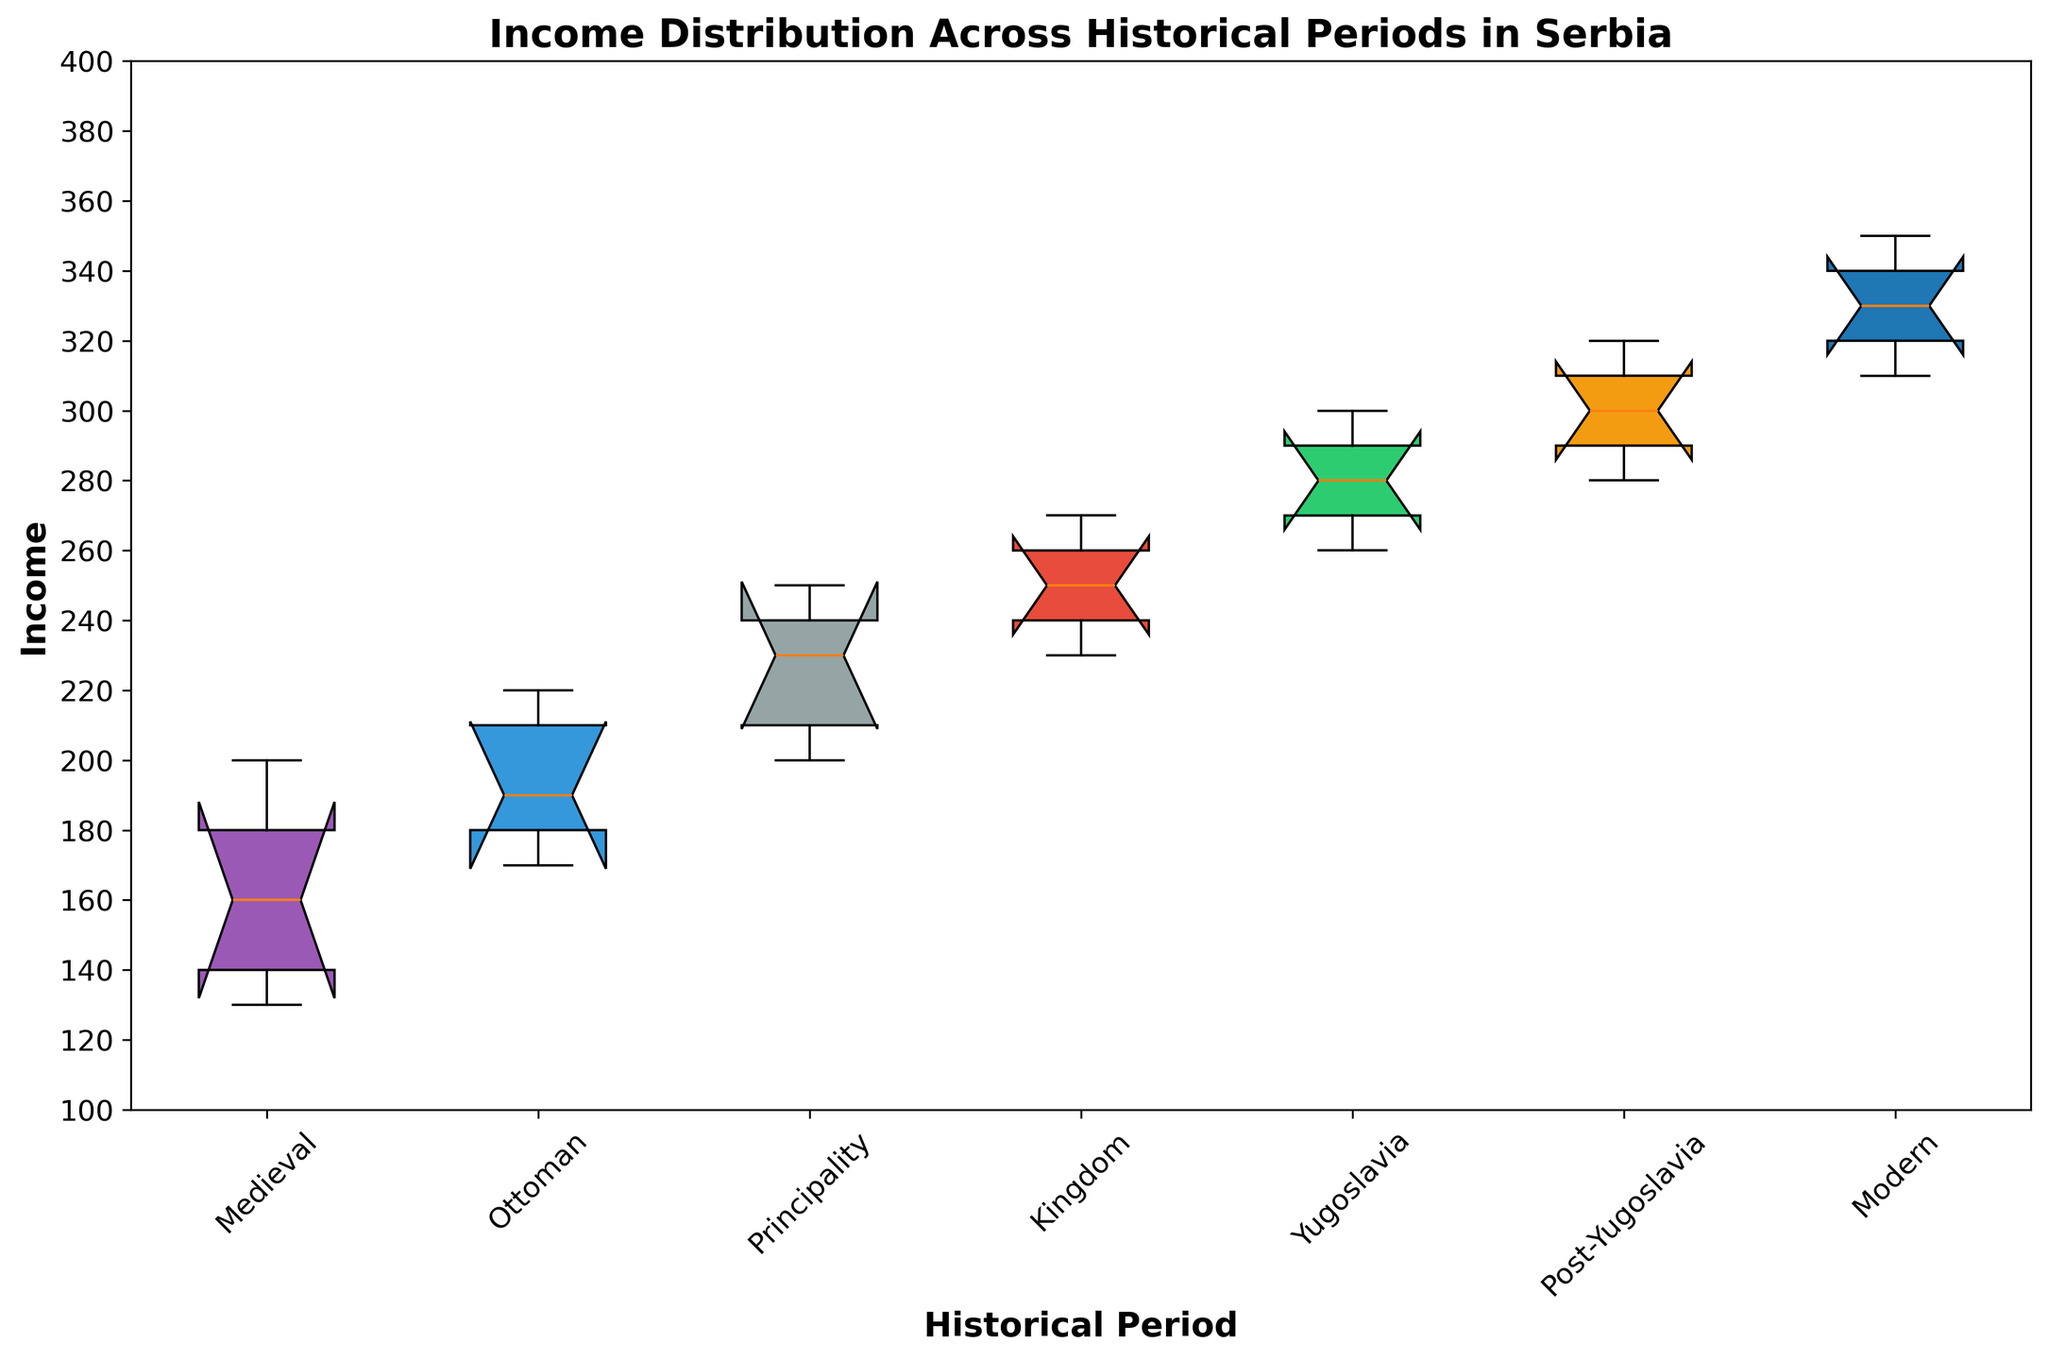What is the median income in the Principality period? The Principality period's box plot will show the distribution of incomes, and the median is marked by the line inside the box. By identifying this line's position, you can determine the median value.
Answer: 230 Which period shows the highest median income? To answer this question, compare the position of the median lines (the lines inside the box) across all periods. The one positioned the highest indicates the highest median income.
Answer: Modern How much did the median income increase from the Medieval to the Modern period? First, find the median income for both the Medieval and Modern periods by identifying the lines inside their respective boxes. Then, calculate the difference between these two values.
Answer: 170 Are the income distributions more spread out in the Medieval period or the Ottoman period? To determine this, compare the lengths of the boxes and whiskers for the Medieval and Ottoman periods. A longer box and whiskers indicate a more spread-out distribution.
Answer: Ottoman In which period is the interquartile range (IQR) the smallest? The IQR is represented by the height of the box in the box plot. Compare the heights of the boxes across all periods to identify the smallest one.
Answer: Yugoslavia Compare the median incomes of Belgrade and Kosovo during the Kingdom period. Identify the median lines for Belgrade and Kosovo within the Kingdom period’s box. Compare their positions to determine the relative incomes.
Answer: Belgrade's median is higher Which region's income shows the least increase when moving from the Ottoman to the Principality period? For each region, find the median income in the Ottoman and Principality periods and calculate the difference. The smallest difference indicates the least increase.
Answer: Kosovo What is the range of incomes in the Post-Yugoslavia period? To find the range, identify the lowest and highest points (ends of the whiskers) in the Post-Yugoslavia period’s box plot, then calculate the difference between these two values.
Answer: 40 Is the variance in income higher in the Kingdom or the Post-Yugoslavia period? Higher variance is usually reflected by a larger spread in the box plot. Compare the lengths of the boxes and the spread of the whiskers in both periods to determine which has a larger spread.
Answer: Post-Yugoslavia What color represents the income distribution for the Medieval period in the figure? In a box plot, different periods are often represented by different colors. Identify the color used for the boxes corresponding to the Medieval period.
Answer: Purple 